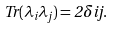<formula> <loc_0><loc_0><loc_500><loc_500>T r ( \lambda _ { i } \lambda _ { j } ) = 2 \delta { i j } .</formula> 